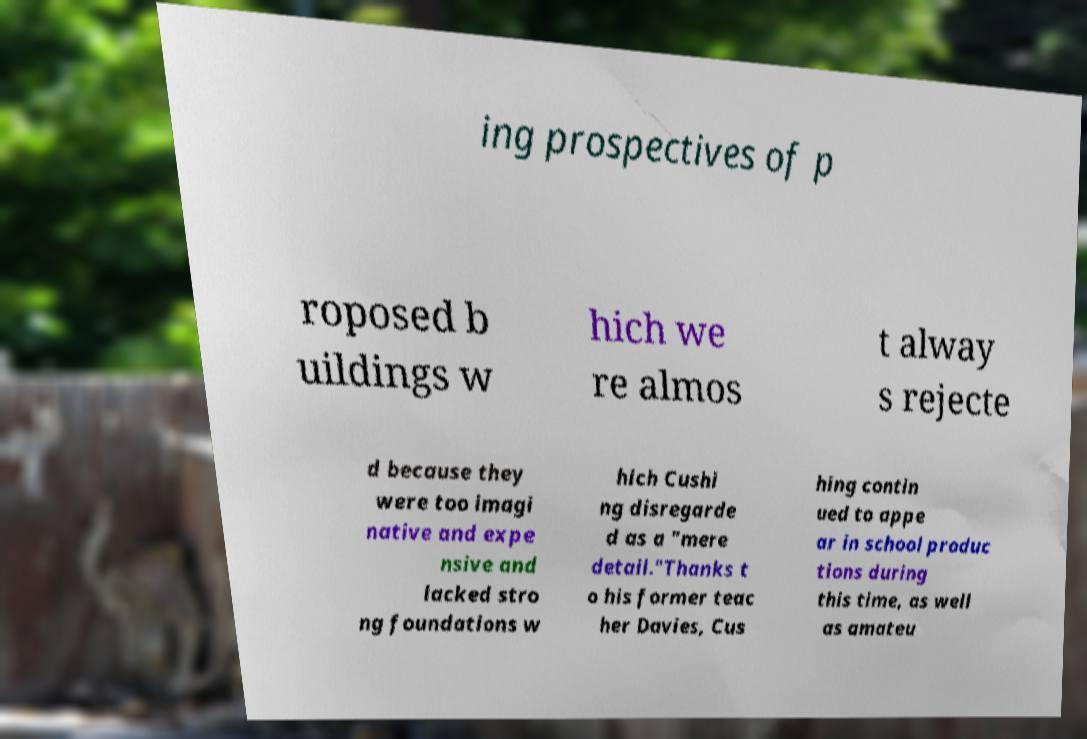Can you accurately transcribe the text from the provided image for me? ing prospectives of p roposed b uildings w hich we re almos t alway s rejecte d because they were too imagi native and expe nsive and lacked stro ng foundations w hich Cushi ng disregarde d as a "mere detail."Thanks t o his former teac her Davies, Cus hing contin ued to appe ar in school produc tions during this time, as well as amateu 